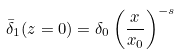Convert formula to latex. <formula><loc_0><loc_0><loc_500><loc_500>\bar { \delta } _ { 1 } ( z = 0 ) = \delta _ { 0 } \left ( \frac { x } { x _ { 0 } } \right ) ^ { - s }</formula> 